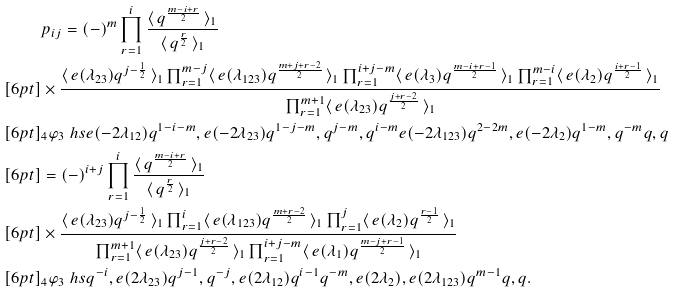<formula> <loc_0><loc_0><loc_500><loc_500>& p _ { i j } = ( - ) ^ { m } \prod _ { r = 1 } ^ { i } \frac { \langle \, q ^ { \frac { m - i + r } { 2 } } \, \rangle _ { 1 } } { \langle \, q ^ { \frac { r } { 2 } } \, \rangle _ { 1 } } \\ [ 6 p t ] & \times \frac { \langle \, e ( \lambda _ { 2 3 } ) q ^ { j - \frac { 1 } { 2 } } \, \rangle _ { 1 } \prod _ { r = 1 } ^ { m - j } \langle \, e ( \lambda _ { 1 2 3 } ) q ^ { \frac { m + j + r - 2 } { 2 } } \, \rangle _ { 1 } \prod _ { r = 1 } ^ { i + j - m } \langle \, e ( \lambda _ { 3 } ) q ^ { \frac { m - i + r - 1 } { 2 } } \, \rangle _ { 1 } \prod _ { r = 1 } ^ { m - i } \langle \, e ( \lambda _ { 2 } ) q ^ { \frac { i + r - 1 } { 2 } } \, \rangle _ { 1 } } { \prod _ { r = 1 } ^ { m + 1 } \langle \, e ( \lambda _ { 2 3 } ) q ^ { \frac { j + r - 2 } { 2 } } \, \rangle _ { 1 } } \\ [ 6 p t ] & _ { 4 } \varphi _ { 3 } \ h s { e ( - 2 \lambda _ { 1 2 } ) q ^ { 1 - i - m } , e ( - 2 \lambda _ { 2 3 } ) q ^ { 1 - j - m } , q ^ { j - m } , q ^ { i - m } } { e ( - 2 \lambda _ { 1 2 3 } ) q ^ { 2 - 2 m } , e ( - 2 \lambda _ { 2 } ) q ^ { 1 - m } , q ^ { - m } } { q , q } \\ [ 6 p t ] & = ( - ) ^ { i + j } \prod _ { r = 1 } ^ { i } \frac { \langle \, q ^ { \frac { m - i + r } { 2 } } \, \rangle _ { 1 } } { \langle \, q ^ { \frac { r } { 2 } } \, \rangle _ { 1 } } \\ [ 6 p t ] & \times \frac { \langle \, e ( \lambda _ { 2 3 } ) q ^ { j - \frac { 1 } { 2 } } \, \rangle _ { 1 } \prod _ { r = 1 } ^ { i } \langle \, e ( \lambda _ { 1 2 3 } ) q ^ { \frac { m + r - 2 } { 2 } } \, \rangle _ { 1 } \prod _ { r = 1 } ^ { j } \langle \, e ( \lambda _ { 2 } ) q ^ { \frac { r - 1 } { 2 } } \, \rangle _ { 1 } } { \prod _ { r = 1 } ^ { m + 1 } \langle \, e ( \lambda _ { 2 3 } ) q ^ { \frac { j + r - 2 } { 2 } } \, \rangle _ { 1 } \prod _ { r = 1 } ^ { i + j - m } \langle \, e ( \lambda _ { 1 } ) q ^ { \frac { m - j + r - 1 } { 2 } } \, \rangle _ { 1 } } \\ [ 6 p t ] & _ { 4 } \varphi _ { 3 } \ h s { q ^ { - i } , e ( 2 \lambda _ { 2 3 } ) q ^ { j - 1 } , q ^ { - j } , e ( 2 \lambda _ { 1 2 } ) q ^ { i - 1 } } { q ^ { - m } , e ( 2 \lambda _ { 2 } ) , e ( 2 \lambda _ { 1 2 3 } ) q ^ { m - 1 } } { q , q } .</formula> 